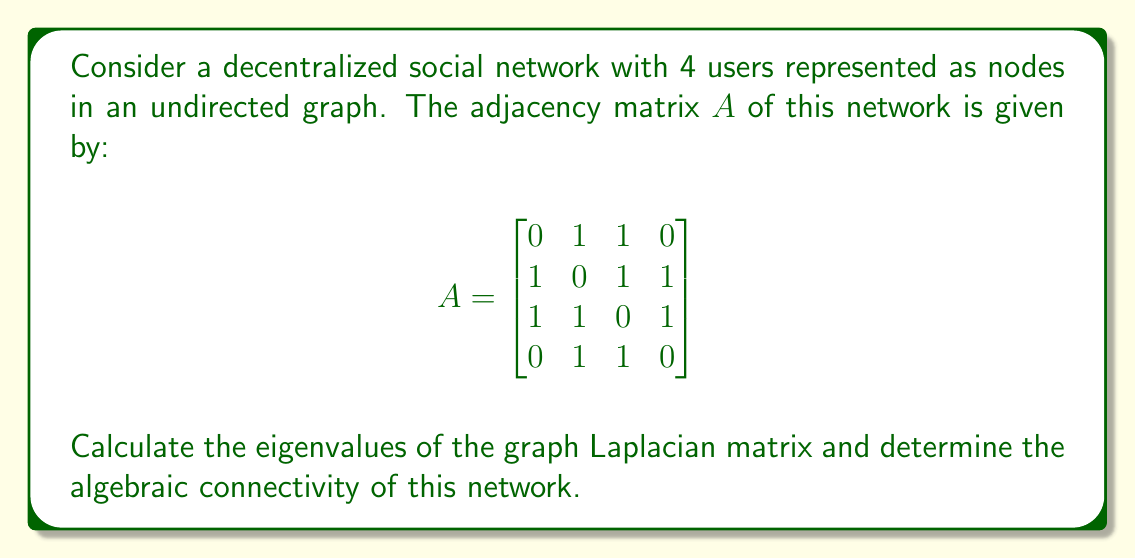Help me with this question. To solve this problem, we'll follow these steps:

1) First, we need to calculate the degree matrix $D$. The degree of each node is the sum of its connections:
   $$D = \begin{bmatrix}
   2 & 0 & 0 & 0 \\
   0 & 3 & 0 & 0 \\
   0 & 0 & 3 & 0 \\
   0 & 0 & 0 & 2
   \end{bmatrix}$$

2) Now, we can calculate the graph Laplacian matrix $L = D - A$:
   $$L = \begin{bmatrix}
   2 & -1 & -1 & 0 \\
   -1 & 3 & -1 & -1 \\
   -1 & -1 & 3 & -1 \\
   0 & -1 & -1 & 2
   \end{bmatrix}$$

3) To find the eigenvalues, we need to solve the characteristic equation $\det(L - \lambda I) = 0$:
   $$\det\begin{bmatrix}
   2-\lambda & -1 & -1 & 0 \\
   -1 & 3-\lambda & -1 & -1 \\
   -1 & -1 & 3-\lambda & -1 \\
   0 & -1 & -1 & 2-\lambda
   \end{bmatrix} = 0$$

4) Solving this equation (which can be done using computer algebra systems for efficiency), we get the eigenvalues:
   $\lambda_1 = 0$
   $\lambda_2 = 1$
   $\lambda_3 = 4$
   $\lambda_4 = 5$

5) The algebraic connectivity is defined as the second smallest eigenvalue of the graph Laplacian. In this case, it's $\lambda_2 = 1$.

This algebraic connectivity value indicates the network's robustness against node/edge failures and its synchronizability, which are crucial factors in decentralized networks aiming to protect user privacy and resist censorship.
Answer: Eigenvalues: $0, 1, 4, 5$; Algebraic connectivity: $1$ 